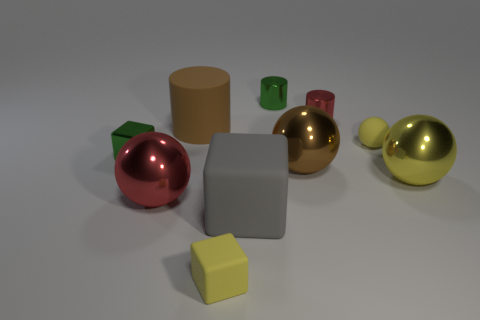Are there any other things that have the same color as the tiny ball?
Offer a terse response. Yes. What is the shape of the green thing that is behind the cube that is left of the shiny sphere on the left side of the large brown metal object?
Your answer should be compact. Cylinder. There is a shiny ball to the left of the big gray thing; is its size the same as the yellow object to the left of the small green cylinder?
Provide a succinct answer. No. What number of big brown spheres have the same material as the large red object?
Make the answer very short. 1. There is a big sphere left of the brown object left of the large brown metallic object; how many small red metallic cylinders are behind it?
Make the answer very short. 1. Is the brown rubber thing the same shape as the yellow metal thing?
Your response must be concise. No. Are there any matte objects of the same shape as the small red metal object?
Provide a succinct answer. Yes. There is a yellow metallic thing that is the same size as the gray rubber cube; what shape is it?
Offer a terse response. Sphere. What is the material of the ball that is left of the green metallic thing behind the green shiny object on the left side of the large red sphere?
Offer a very short reply. Metal. Do the yellow rubber ball and the red cylinder have the same size?
Offer a very short reply. Yes. 